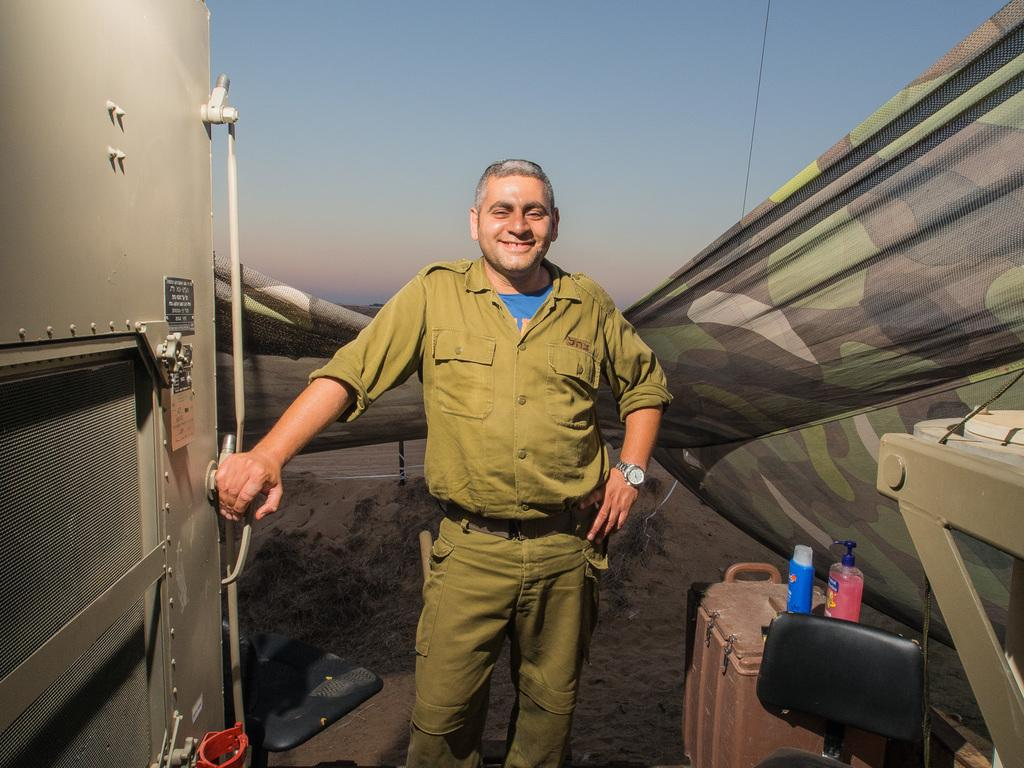What is the person in the image doing with the door? The person is holding a door in the image. What objects are on the box in the image? There are bottles on a box in the image. What type of material is the cloth made of in the image? The cloth in the image is not described in detail, so we cannot determine the material. What can be seen in the background of the image? The sky is visible in the image. What type of prose is being recited by the boys in the image? There are no boys or prose present in the image; it features a person holding a door and bottles on a box. What type of gate is visible in the image? There is no gate present in the image. 